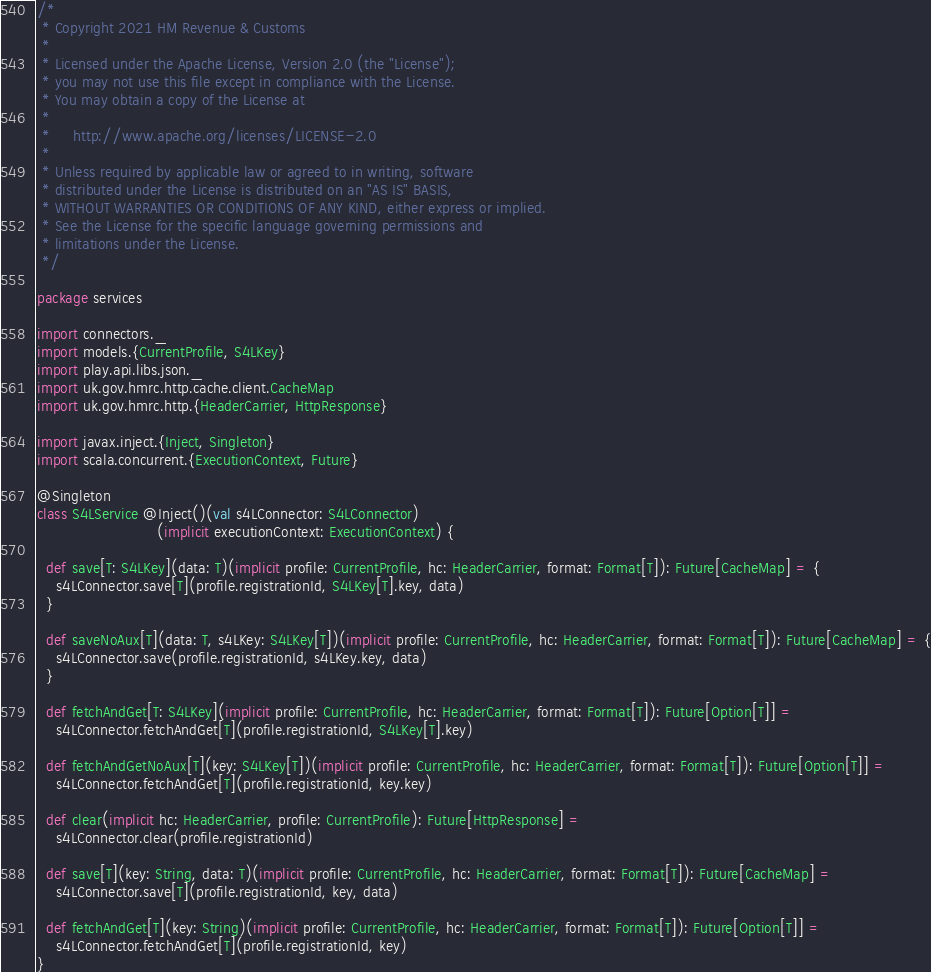Convert code to text. <code><loc_0><loc_0><loc_500><loc_500><_Scala_>/*
 * Copyright 2021 HM Revenue & Customs
 *
 * Licensed under the Apache License, Version 2.0 (the "License");
 * you may not use this file except in compliance with the License.
 * You may obtain a copy of the License at
 *
 *     http://www.apache.org/licenses/LICENSE-2.0
 *
 * Unless required by applicable law or agreed to in writing, software
 * distributed under the License is distributed on an "AS IS" BASIS,
 * WITHOUT WARRANTIES OR CONDITIONS OF ANY KIND, either express or implied.
 * See the License for the specific language governing permissions and
 * limitations under the License.
 */

package services

import connectors._
import models.{CurrentProfile, S4LKey}
import play.api.libs.json._
import uk.gov.hmrc.http.cache.client.CacheMap
import uk.gov.hmrc.http.{HeaderCarrier, HttpResponse}

import javax.inject.{Inject, Singleton}
import scala.concurrent.{ExecutionContext, Future}

@Singleton
class S4LService @Inject()(val s4LConnector: S4LConnector)
                          (implicit executionContext: ExecutionContext) {

  def save[T: S4LKey](data: T)(implicit profile: CurrentProfile, hc: HeaderCarrier, format: Format[T]): Future[CacheMap] = {
    s4LConnector.save[T](profile.registrationId, S4LKey[T].key, data)
  }

  def saveNoAux[T](data: T, s4LKey: S4LKey[T])(implicit profile: CurrentProfile, hc: HeaderCarrier, format: Format[T]): Future[CacheMap] = {
    s4LConnector.save(profile.registrationId, s4LKey.key, data)
  }

  def fetchAndGet[T: S4LKey](implicit profile: CurrentProfile, hc: HeaderCarrier, format: Format[T]): Future[Option[T]] =
    s4LConnector.fetchAndGet[T](profile.registrationId, S4LKey[T].key)

  def fetchAndGetNoAux[T](key: S4LKey[T])(implicit profile: CurrentProfile, hc: HeaderCarrier, format: Format[T]): Future[Option[T]] =
    s4LConnector.fetchAndGet[T](profile.registrationId, key.key)

  def clear(implicit hc: HeaderCarrier, profile: CurrentProfile): Future[HttpResponse] =
    s4LConnector.clear(profile.registrationId)

  def save[T](key: String, data: T)(implicit profile: CurrentProfile, hc: HeaderCarrier, format: Format[T]): Future[CacheMap] =
    s4LConnector.save[T](profile.registrationId, key, data)

  def fetchAndGet[T](key: String)(implicit profile: CurrentProfile, hc: HeaderCarrier, format: Format[T]): Future[Option[T]] =
    s4LConnector.fetchAndGet[T](profile.registrationId, key)
}
</code> 